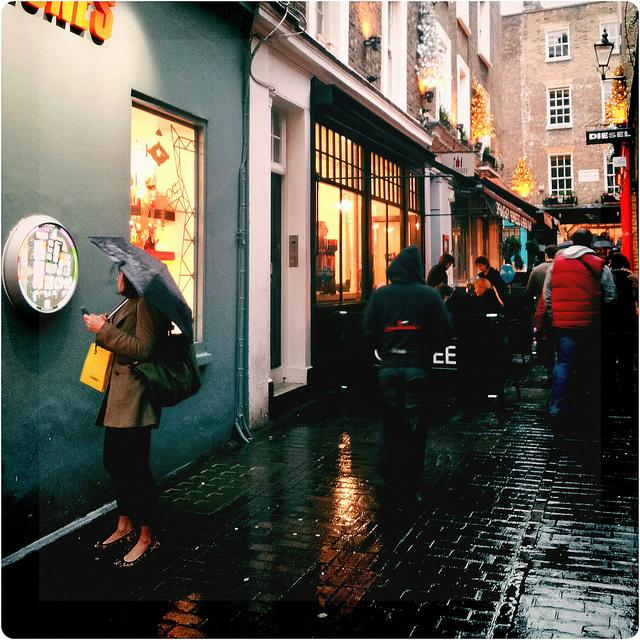What has made the ground shiny?

Choices:
A) snow
B) water
C) wax
D) oil water 